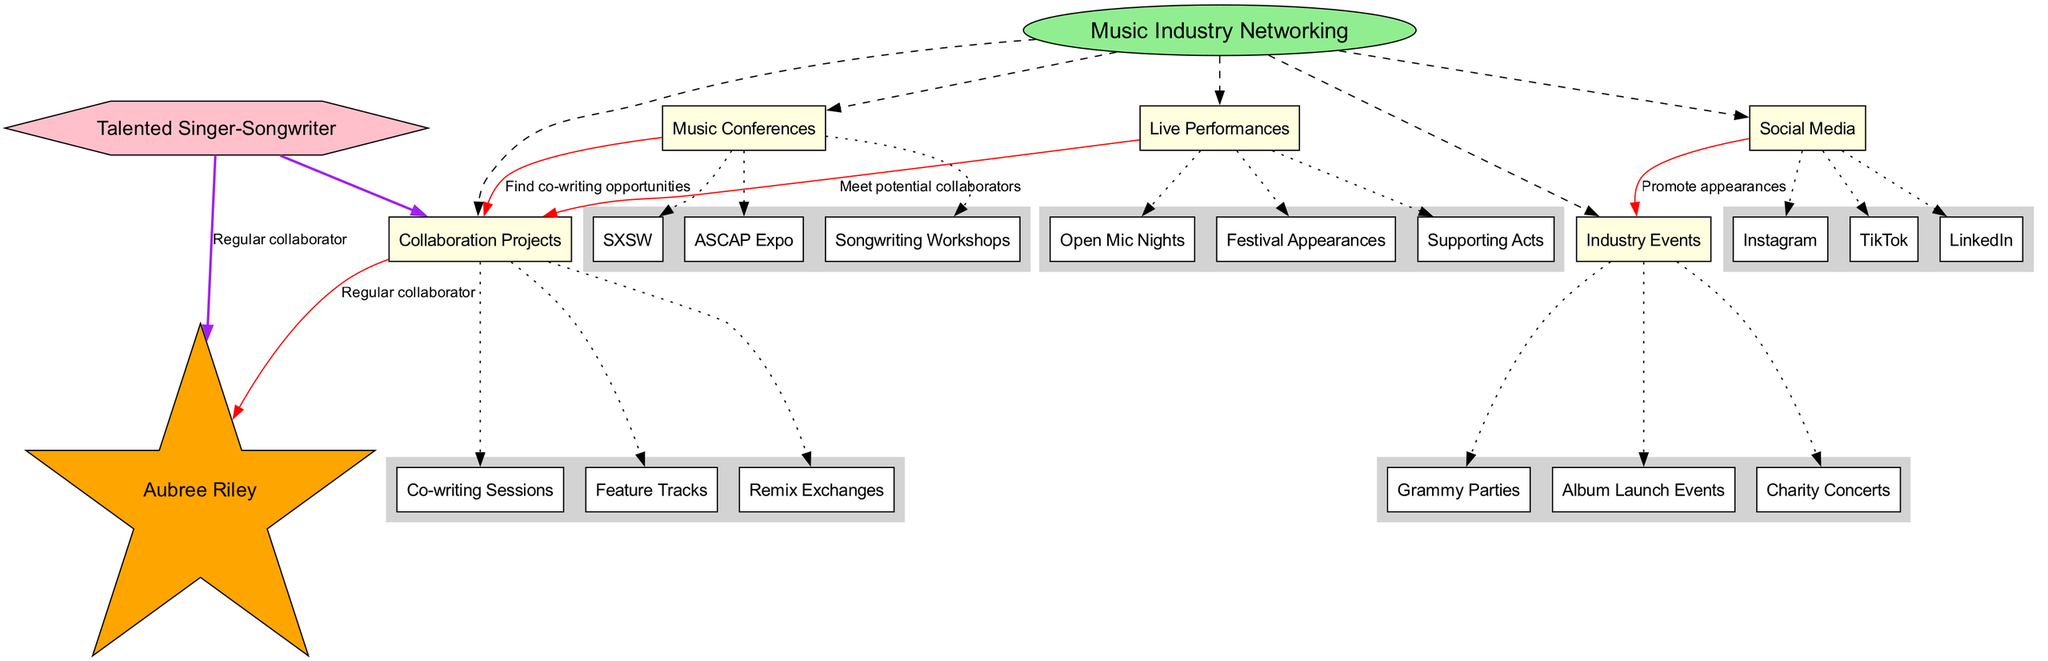What is the central concept of the diagram? The diagram explicitly states that the central concept is "Music Industry Networking." This can be found in the central node labeled with a distinctly different shape and color.
Answer: Music Industry Networking How many main nodes are there? By counting the main nodes listed, we see there are five main nodes: Live Performances, Social Media, Music Conferences, Collaboration Projects, and Industry Events.
Answer: 5 What is one type of collaboration project? The diagram contains a section for "Collaboration Projects" with examples that include "Co-writing Sessions," "Feature Tracks," and "Remix Exchanges." Any of these can be accepted, but "Co-writing Sessions" is representative.
Answer: Co-writing Sessions What connects Social Media to Industry Events? The diagram shows a red edge labeled "Promote appearances," indicating the relationship between Social Media and Industry Events. This can be found in the connections section.
Answer: Promote appearances How does Live Performances relate to Collaboration Projects? The connection specified in the diagram that links these two nodes indicates that one can "Meet potential collaborators" through Live Performances, providing an avenue for collaboration.
Answer: Meet potential collaborators Which music conference is listed in the diagram? The node labeled "Music Conferences" showcases three examples: "SXSW," "ASCAP Expo," and "Songwriting Workshops." Any of these would be correct, but "SXSW" stands out as a well-known example.
Answer: SXSW What relationship does the persona have with Aubree Riley? The diagram clearly illustrates a direct connection from the persona "Talented Singer-Songwriter" to "Aubree Riley," with the relationship labeled as "Regular collaborator." This indicates a consistent partnership.
Answer: Regular collaborator What is one sub-node under Industry Events? The sub-nodes under "Industry Events" include "Grammy Parties," "Album Launch Events," and "Charity Concerts." Any of these can be selected as a correct answer, but "Grammy Parties" is particularly notable.
Answer: Grammy Parties What type of relationship is depicted from Music Conferences to Collaboration Projects? The diagram indicates a connection with the label "Find co-writing opportunities," suggesting that attendance at Music Conferences can lead to collaboration opportunities.
Answer: Find co-writing opportunities 